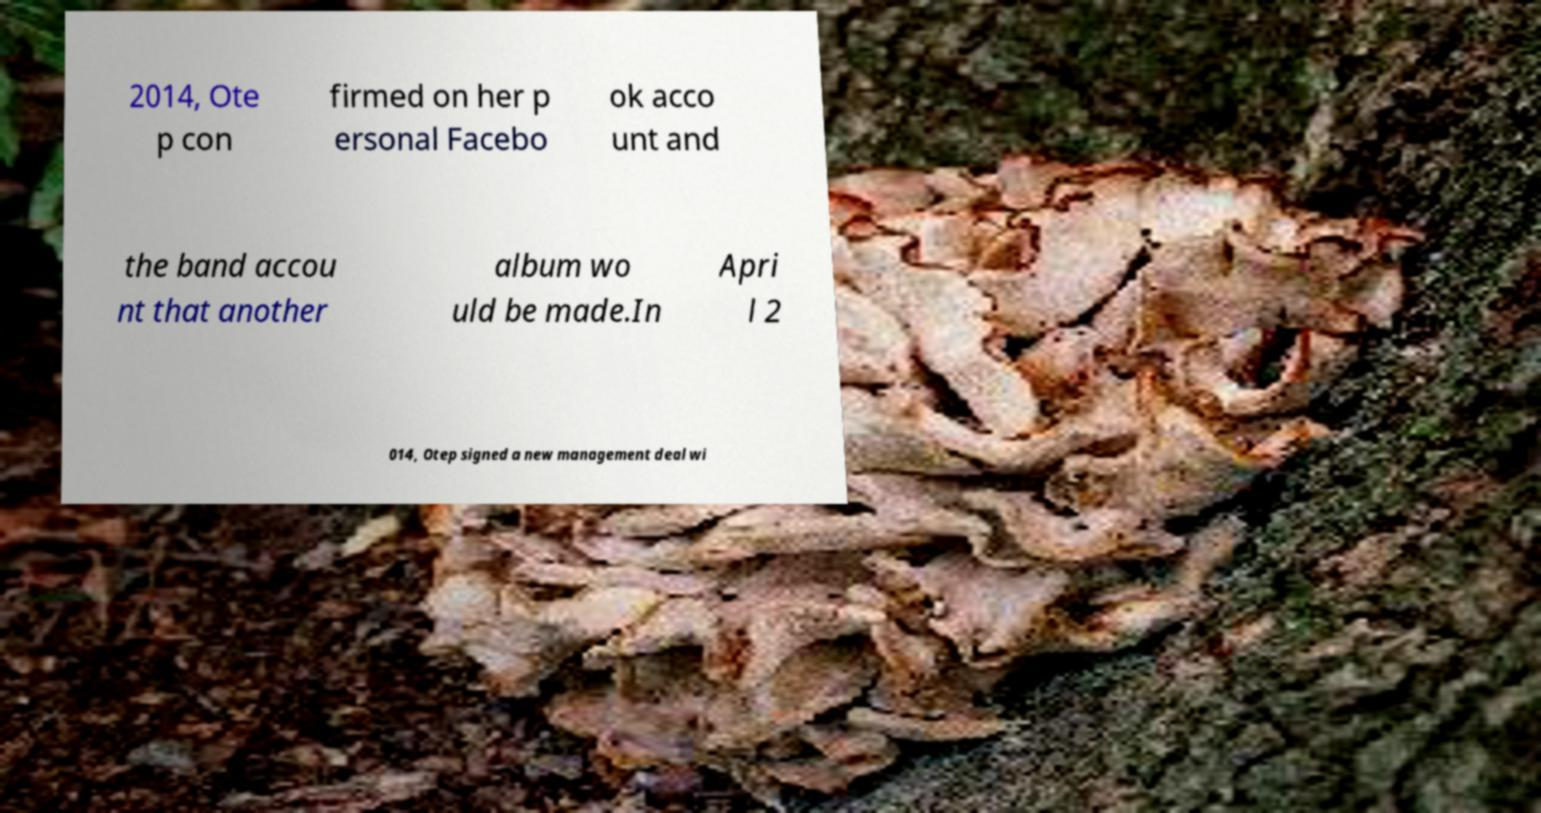Please read and relay the text visible in this image. What does it say? 2014, Ote p con firmed on her p ersonal Facebo ok acco unt and the band accou nt that another album wo uld be made.In Apri l 2 014, Otep signed a new management deal wi 